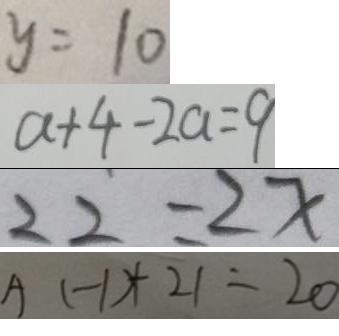Convert formula to latex. <formula><loc_0><loc_0><loc_500><loc_500>y = 1 0 
 a + 4 - 2 a = 9 
 2 2 = 2 x 
 A ( - 1 ) + 2 1 = 2 0</formula> 